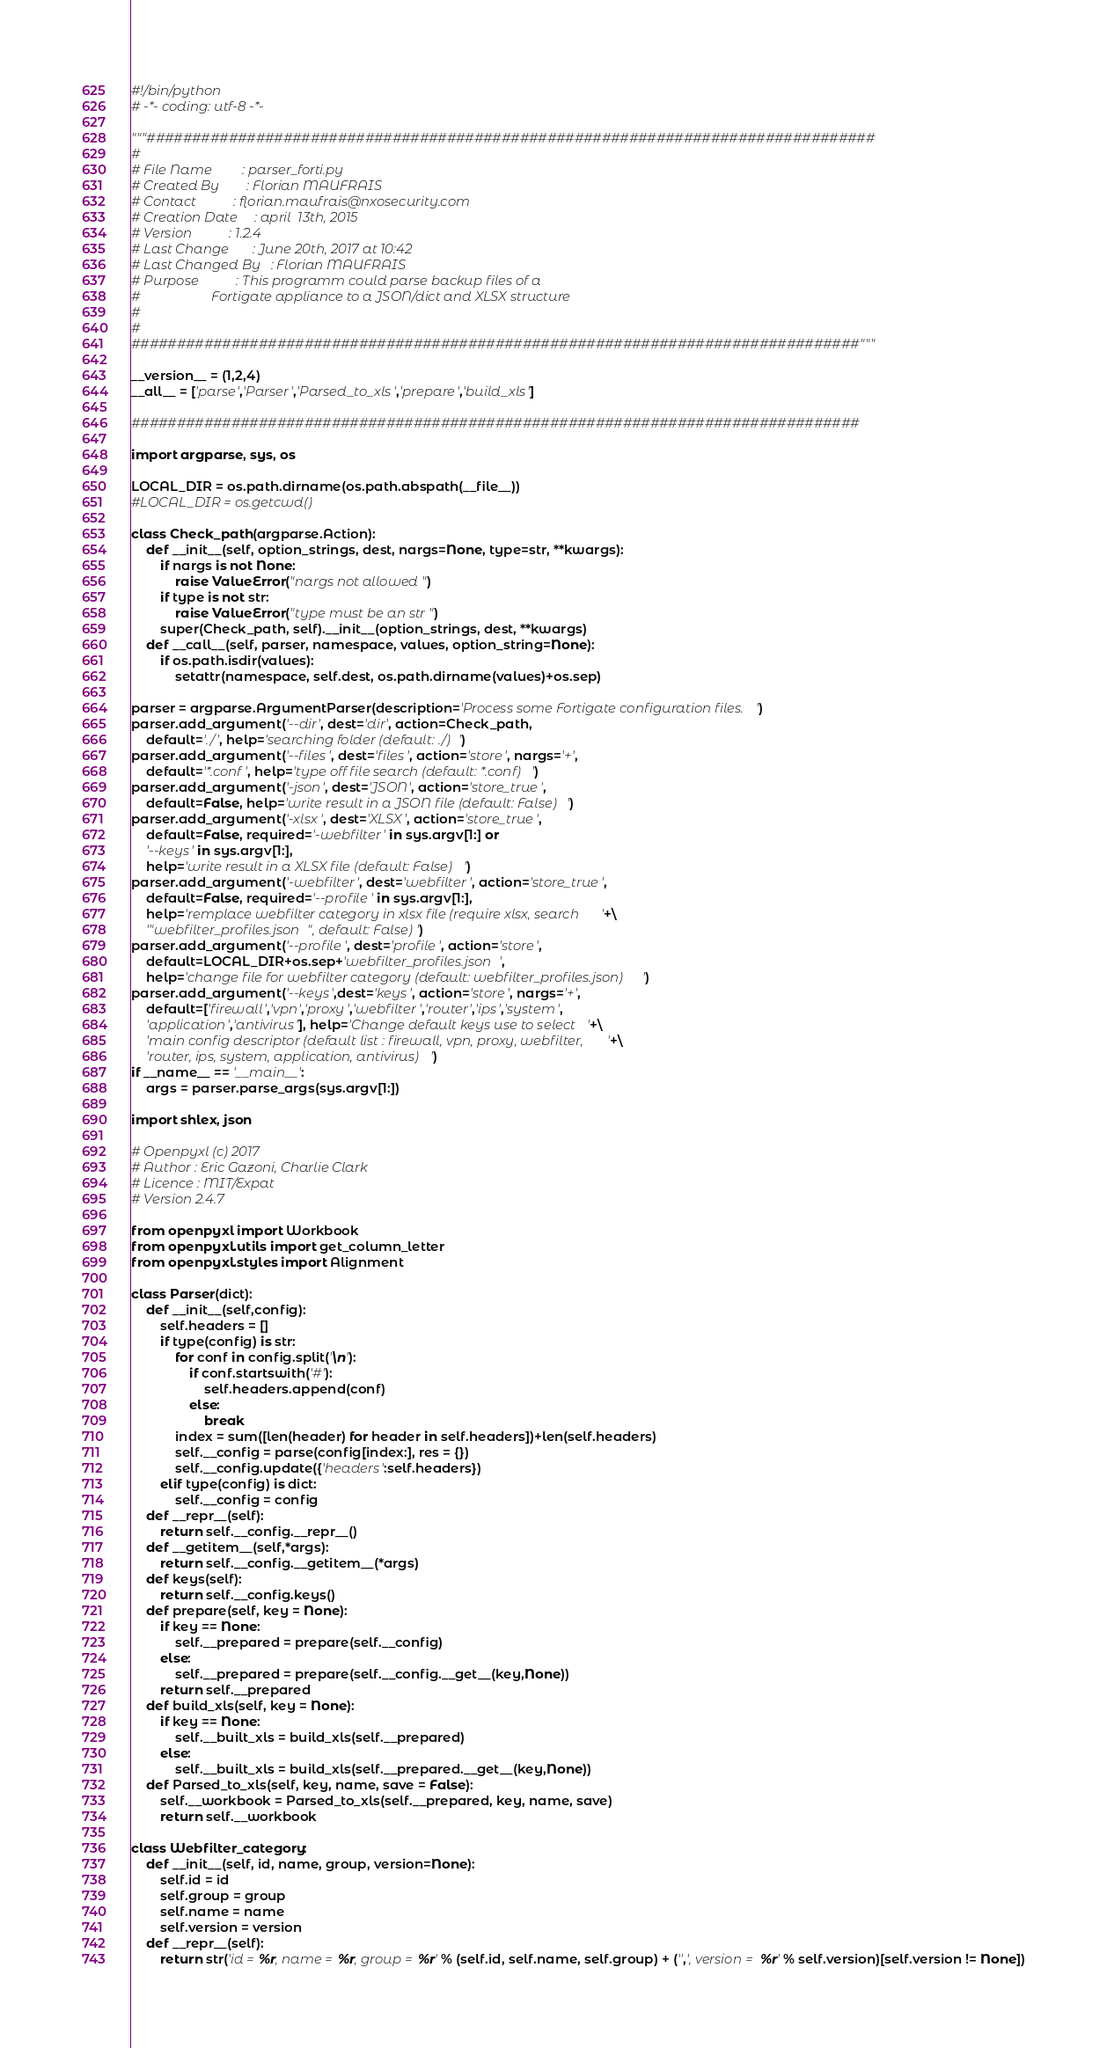Convert code to text. <code><loc_0><loc_0><loc_500><loc_500><_Python_>#!/bin/python
# -*- coding: utf-8 -*-

"""################################################################################
#
# File Name         : parser_forti.py
# Created By        : Florian MAUFRAIS
# Contact           : florian.maufrais@nxosecurity.com
# Creation Date     : april  13th, 2015
# Version           : 1.2.4
# Last Change       : June 20th, 2017 at 10:42
# Last Changed By   : Florian MAUFRAIS
# Purpose           : This programm could parse backup files of a
#                     Fortigate appliance to a JSON/dict and XLSX structure
#
#
################################################################################"""

__version__ = (1,2,4)
__all__ = ['parse','Parser','Parsed_to_xls','prepare','build_xls']

################################################################################

import argparse, sys, os

LOCAL_DIR = os.path.dirname(os.path.abspath(__file__))
#LOCAL_DIR = os.getcwd()

class Check_path(argparse.Action):
    def __init__(self, option_strings, dest, nargs=None, type=str, **kwargs):
        if nargs is not None:
            raise ValueError("nargs not allowed")
        if type is not str:
            raise ValueError("type must be an str")
        super(Check_path, self).__init__(option_strings, dest, **kwargs)
    def __call__(self, parser, namespace, values, option_string=None):
        if os.path.isdir(values):
            setattr(namespace, self.dest, os.path.dirname(values)+os.sep)

parser = argparse.ArgumentParser(description='Process some Fortigate configuration files.')
parser.add_argument('--dir', dest='dir', action=Check_path,
    default='./', help='searching folder (default: ./)')
parser.add_argument('--files', dest='files', action='store', nargs='+',
    default='*.conf', help='type off file search (default: *.conf)')
parser.add_argument('-json', dest='JSON', action='store_true',
    default=False, help='write result in a JSON file (default: False)')
parser.add_argument('-xlsx', dest='XLSX', action='store_true',
    default=False, required='-webfilter' in sys.argv[1:] or 
    '--keys' in sys.argv[1:],
    help='write result in a XLSX file (default: False)')
parser.add_argument('-webfilter', dest='webfilter', action='store_true',
    default=False, required='--profile' in sys.argv[1:],
    help='remplace webfilter category in xlsx file (require xlsx, search '+\
    '"webfilter_profiles.json", default: False)')
parser.add_argument('--profile', dest='profile', action='store',
    default=LOCAL_DIR+os.sep+'webfilter_profiles.json', 
    help='change file for webfilter category (default: webfilter_profiles.json)')
parser.add_argument('--keys',dest='keys', action='store', nargs='+',
    default=['firewall','vpn','proxy','webfilter','router','ips','system',
    'application','antivirus'], help='Change default keys use to select '+\
    'main config descriptor (default list : firewall, vpn, proxy, webfilter, '+\
    'router, ips, system, application, antivirus)')
if __name__ == '__main__':
    args = parser.parse_args(sys.argv[1:])

import shlex, json

# Openpyxl (c) 2017
# Author : Eric Gazoni, Charlie Clark
# Licence : MIT/Expat
# Version 2.4.7

from openpyxl import Workbook
from openpyxl.utils import get_column_letter
from openpyxl.styles import Alignment

class Parser(dict):
    def __init__(self,config):
        self.headers = []
        if type(config) is str:
            for conf in config.split('\n'):
                if conf.startswith('#'):
                    self.headers.append(conf)
                else: 
                    break
            index = sum([len(header) for header in self.headers])+len(self.headers)
            self.__config = parse(config[index:], res = {})
            self.__config.update({'headers':self.headers})
        elif type(config) is dict:
            self.__config = config
    def __repr__(self):
        return self.__config.__repr__()
    def __getitem__(self,*args):
        return self.__config.__getitem__(*args)
    def keys(self):
        return self.__config.keys()
    def prepare(self, key = None):
        if key == None:
            self.__prepared = prepare(self.__config)
        else:
            self.__prepared = prepare(self.__config.__get__(key,None))
        return self.__prepared
    def build_xls(self, key = None):
        if key == None:
            self.__built_xls = build_xls(self.__prepared)
        else:
            self.__built_xls = build_xls(self.__prepared.__get__(key,None))
    def Parsed_to_xls(self, key, name, save = False):
        self.__workbook = Parsed_to_xls(self.__prepared, key, name, save)
        return self.__workbook

class Webfilter_category:
    def __init__(self, id, name, group, version=None):
        self.id = id
        self.group = group
        self.name = name
        self.version = version
    def __repr__(self):
        return str('id = %r, name = %r, group = %r' % (self.id, self.name, self.group) + ('',', version = %r' % self.version)[self.version != None])
</code> 